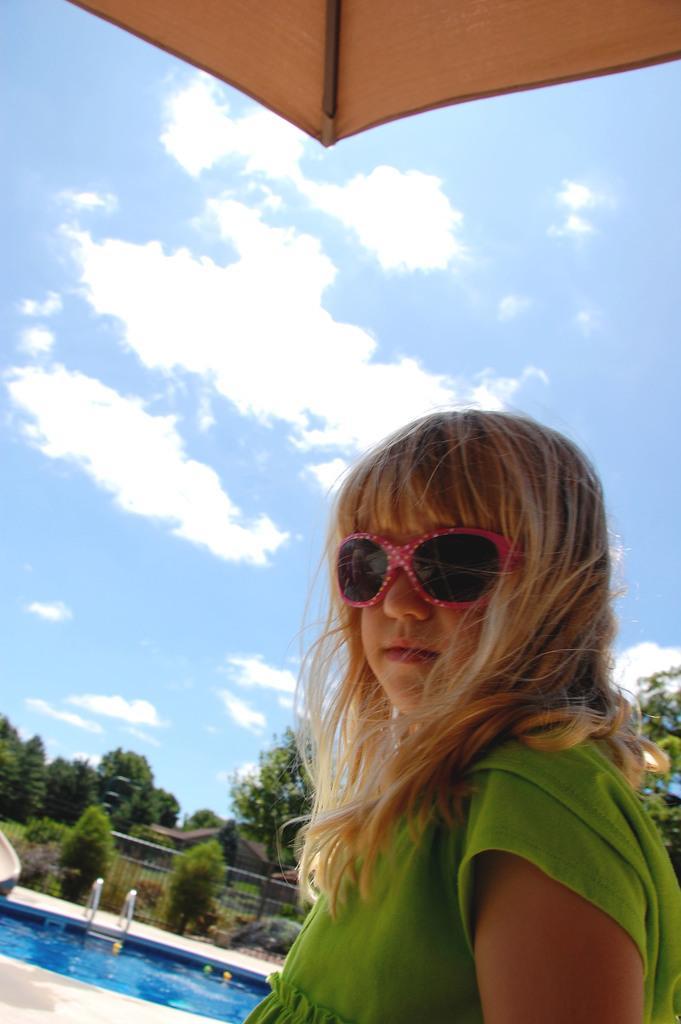Can you describe this image briefly? In this picture we can see a person in the front, in the background there are some trees, grass and a swimming pool, there is fencing in the middle, it looks like a house in the background, there is the sky, clouds and an umbrella at the top of the picture. 